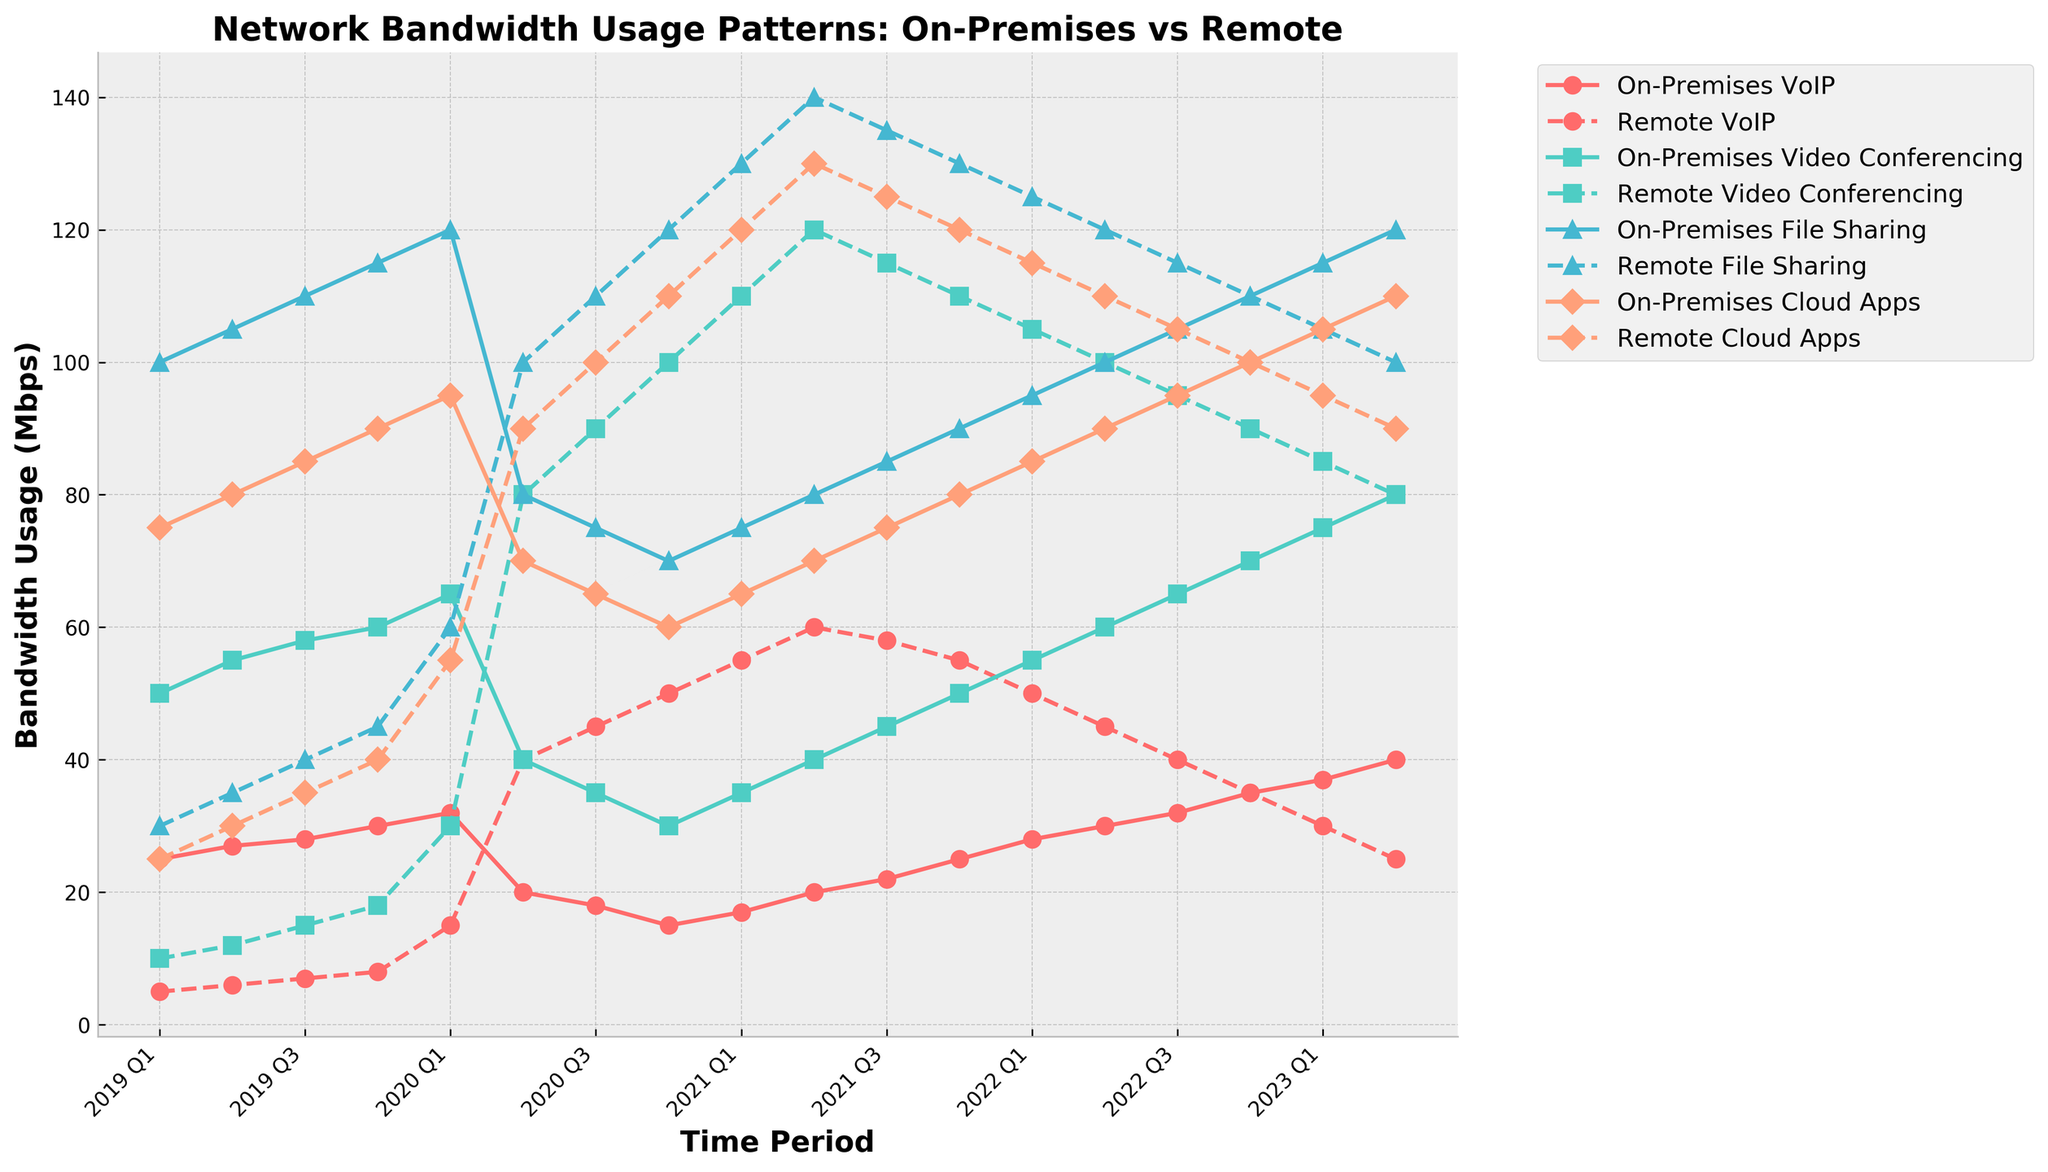Which time period experienced the highest bandwidth usage for on-premises VoIP? Look for the peak value in the on-premises VoIP line, which corresponds to the highest point. This occurs in Q2 2023 at 40 Mbps.
Answer: Q2 2023 How does the bandwidth usage for remote video conferencing in Q2 2020 compare to the on-premises setup? In Q2 2020, remote video conferencing usage is 80 Mbps, while on-premises usage is 40 Mbps. This means remote is double the on-premises usage for that quarter.
Answer: Remote is double the on-premises What's the overall trend for on-premises cloud apps from 2019 to 2023? Examine the on-premises cloud apps line from 2019 to 2023. The overall trend is gradually increasing from 75 Mbps to 110 Mbps with some fluctuations.
Answer: Gradually increasing Compare the bandwidth usage for on-premises and remote file sharing in Q3 2021. Which is higher? In Q3 2021, the on-premises file sharing usage is 85 Mbps, and the remote file sharing usage is 135 Mbps. Thus, remote usage is higher.
Answer: Remote is higher What is the average bandwidth usage of on-premises video conferencing from Q1 2020 to Q4 2020? The values for Q1 to Q4 2020 are 65, 40, 35, and 30 Mbps. Sum them: 65 + 40 + 35 + 30 = 170, then divide by 4: 170 / 4 = 42.5 Mbps.
Answer: 42.5 Mbps In which quarter did remote VoIP bandwidth usage see the most significant increase compared to the previous quarter? Identify the steepest upward slope in the remote VoIP line. The most significant increase occurred from Q4 2019 (8 Mbps) to Q1 2020 (15 Mbps), an increase of 7 Mbps.
Answer: Q1 2020 What's the difference in bandwidth usage for remote cloud apps between Q4 2021 and Q1 2022? The values are 120 Mbps for Q4 2021 and 115 Mbps for Q1 2022. The difference is 120 - 115 = 5 Mbps.
Answer: 5 Mbps Compare the visual heights of the on-premises and remote VoIP lines between Q1 2019 and Q1 2020. How did they change? For on-premises VoIP, the height increased from 25 to 32 Mbps. For remote VoIP, the height increased significantly from 5 to 15 Mbps. Both increased, with remote seeing a more dramatic change.
Answer: Both increased; remote increased more During which quarter did on-premises file sharing usage see a sharp decline, and what was the change in Mbps? The largest drop in on-premises file sharing was between Q1 2020 (120 Mbps) and Q2 2020 (80 Mbps), with a decline of 40 Mbps.
Answer: Q2 2020, 40 Mbps What were the relative positions of on-premises and remote video conferencing usage in Q4 2020? In Q4 2020, the on-premises video conferencing usage is 30 Mbps and the remote video conferencing usage is 100 Mbps, so remote is much higher.
Answer: Remote is much higher 